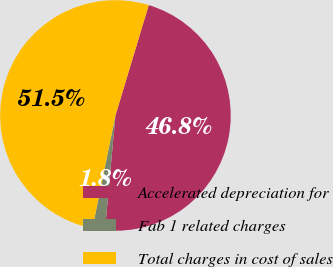<chart> <loc_0><loc_0><loc_500><loc_500><pie_chart><fcel>Accelerated depreciation for<fcel>Fab 1 related charges<fcel>Total charges in cost of sales<nl><fcel>46.78%<fcel>1.75%<fcel>51.46%<nl></chart> 